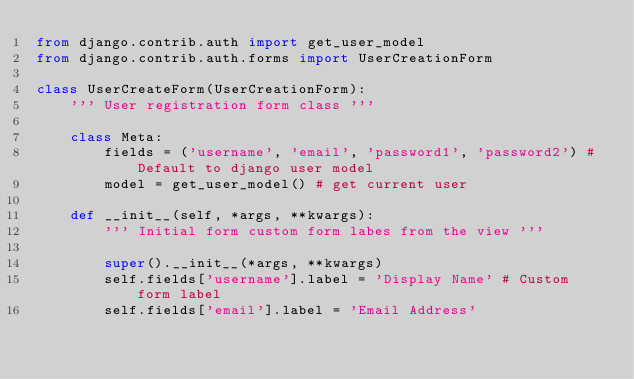<code> <loc_0><loc_0><loc_500><loc_500><_Python_>from django.contrib.auth import get_user_model
from django.contrib.auth.forms import UserCreationForm

class UserCreateForm(UserCreationForm):
	''' User registration form class '''

	class Meta:
		fields = ('username', 'email', 'password1', 'password2') # Default to django user model
		model = get_user_model() # get current user

	def __init__(self, *args, **kwargs):
		''' Initial form custom form labes from the view '''
		
		super().__init__(*args, **kwargs)
		self.fields['username'].label = 'Display Name' # Custom form label
		self.fields['email'].label = 'Email Address'
</code> 